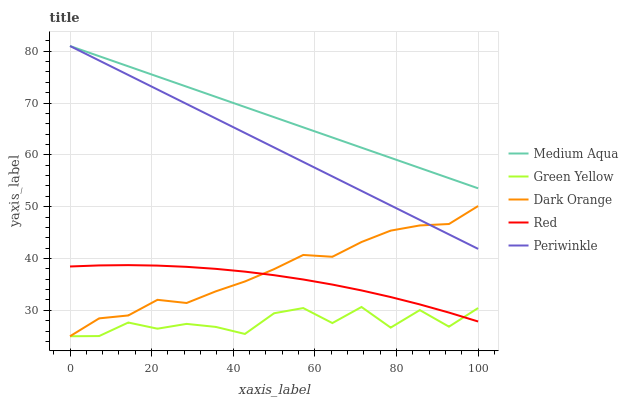Does Green Yellow have the minimum area under the curve?
Answer yes or no. Yes. Does Medium Aqua have the maximum area under the curve?
Answer yes or no. Yes. Does Periwinkle have the minimum area under the curve?
Answer yes or no. No. Does Periwinkle have the maximum area under the curve?
Answer yes or no. No. Is Periwinkle the smoothest?
Answer yes or no. Yes. Is Green Yellow the roughest?
Answer yes or no. Yes. Is Green Yellow the smoothest?
Answer yes or no. No. Is Periwinkle the roughest?
Answer yes or no. No. Does Dark Orange have the lowest value?
Answer yes or no. Yes. Does Periwinkle have the lowest value?
Answer yes or no. No. Does Medium Aqua have the highest value?
Answer yes or no. Yes. Does Green Yellow have the highest value?
Answer yes or no. No. Is Green Yellow less than Medium Aqua?
Answer yes or no. Yes. Is Medium Aqua greater than Green Yellow?
Answer yes or no. Yes. Does Dark Orange intersect Red?
Answer yes or no. Yes. Is Dark Orange less than Red?
Answer yes or no. No. Is Dark Orange greater than Red?
Answer yes or no. No. Does Green Yellow intersect Medium Aqua?
Answer yes or no. No. 